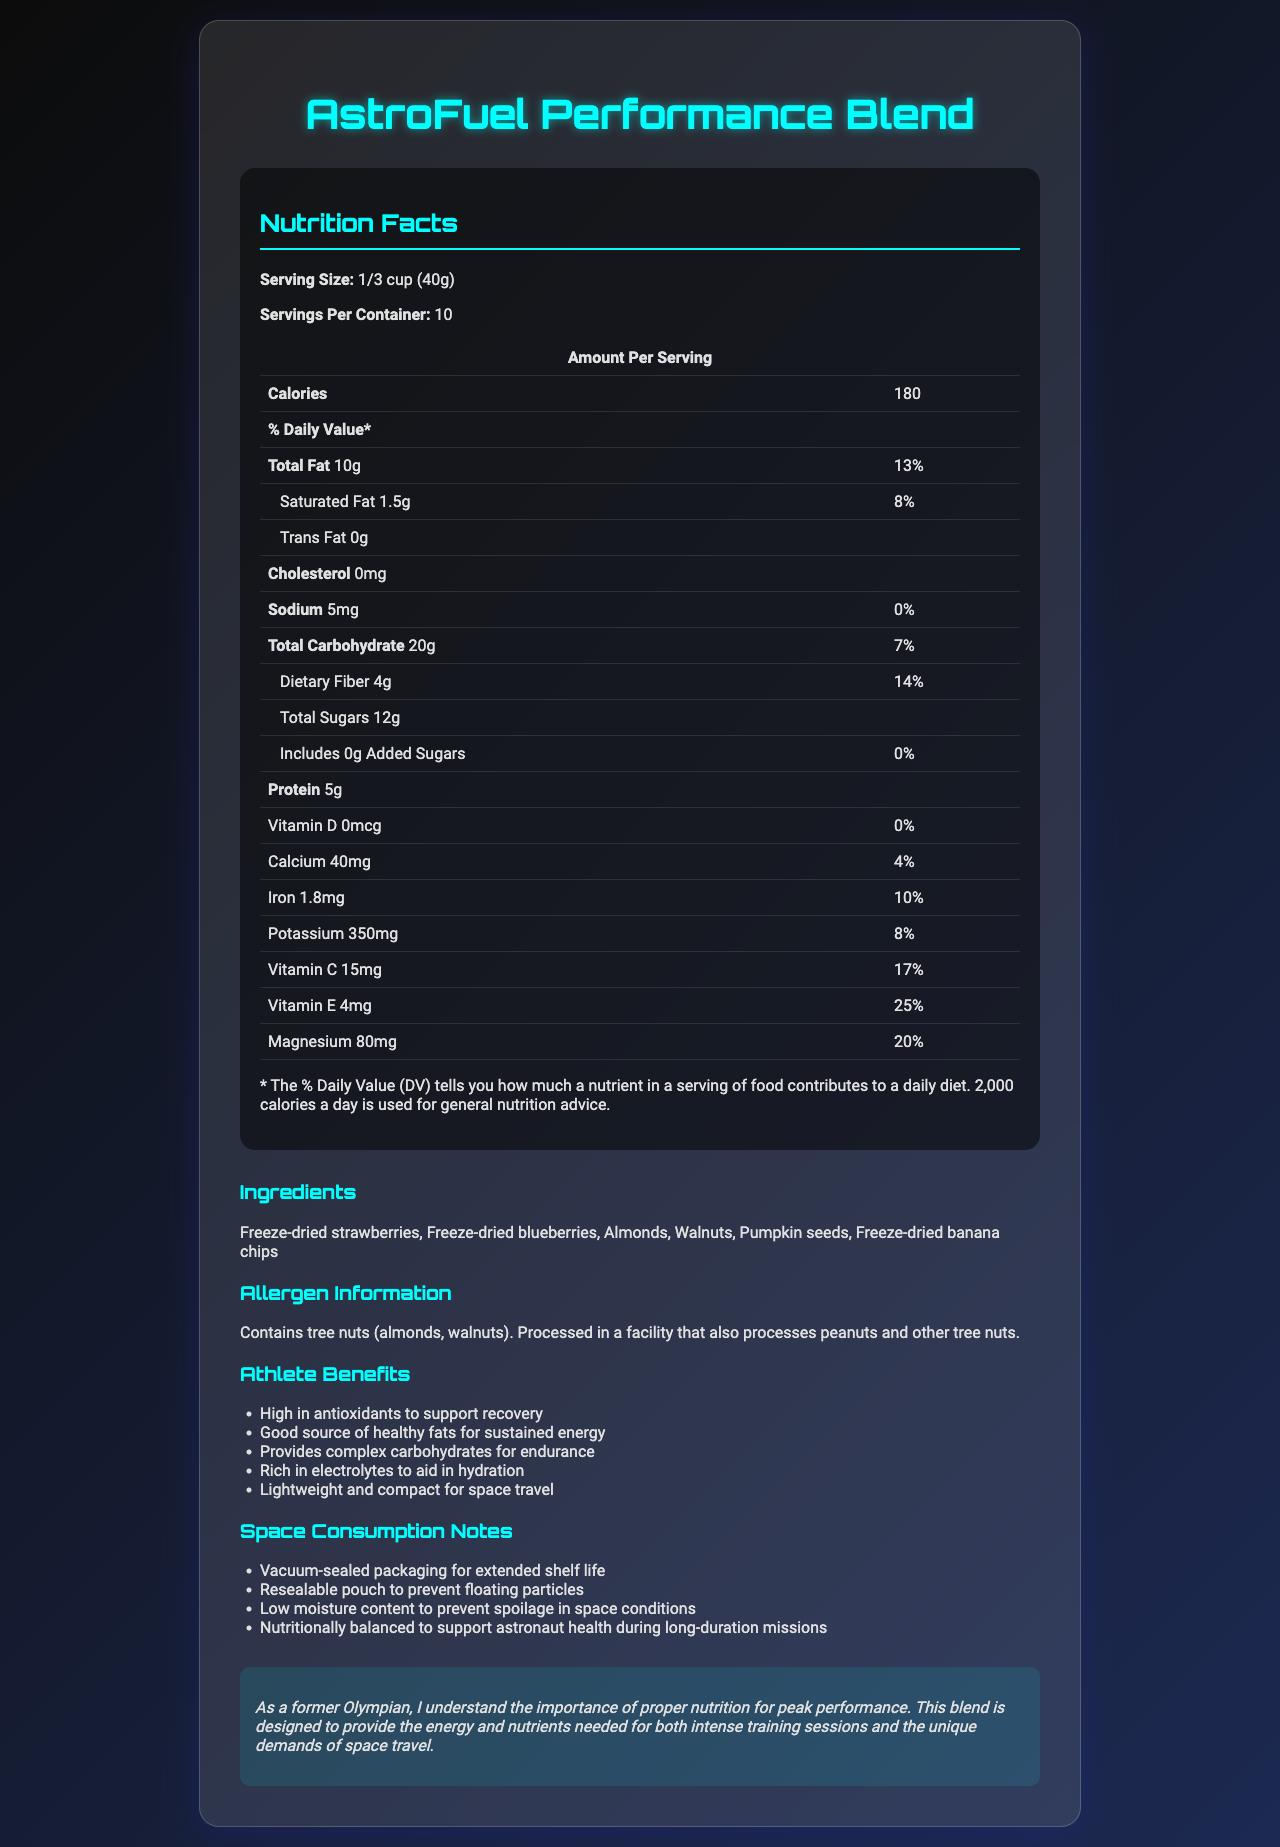what is the serving size? The serving size is explicitly mentioned as 1/3 cup (40g) under the Nutrition Facts section.
Answer: 1/3 cup (40g) how many calories are there per serving? The number of calories per serving is listed as 180 in the Amount Per Serving section of the Nutrition Facts.
Answer: 180 how much total fat does one serving contain? The Total Fat content per serving is shown as 10g in the table under the Nutrition Facts.
Answer: 10g what is the daily value percentage of dietary fiber per serving? The % Daily Value for Dietary Fiber is mentioned as 14% in the Nutrition Facts table.
Answer: 14% what are the primary ingredients in this product? The Ingredients section lists these items as the main ingredients.
Answer: Freeze-dried strawberries, Freeze-dried blueberries, Almonds, Walnuts, Pumpkin seeds, Freeze-dried banana chips does this product contain cholesterol? The Nutrition Facts state that the product contains 0mg of cholesterol, which means it does not contain cholesterol.
Answer: No how much sodium is in one serving? The sodium content per serving is listed as 5mg in the Nutrition Facts.
Answer: 5mg which of the following ingredients does the mix contain? A. Almonds B. Cashews C. Pine nuts D. Peanuts The Ingredients section lists Almonds, but not Cashews, Pine nuts, or Peanuts.
Answer: A. Almonds what benefits are specifically mentioned for athletes? I. High in antioxidants II. Good source of healthy fats III. Increased muscle mass IV. Rich in electrolytes The Athlete Benefits section lists high antioxidants, healthy fats, and rich in electrolytes, but does not mention increased muscle mass.
Answer: I, II, IV is this product suitable for space travel? The Space Consumption Notes section lists multiple features that make this product suitable for space travel.
Answer: Yes summarize the main idea of the document. The document includes information about serving sizes, nutritional content, ingredients, allergen information, and special notes for both athletes and astronauts, emphasizing its high nutrient density and usefulness in strenuous conditions.
Answer: The document provides detailed nutrition facts for the AstroFuel Performance Blend, describes its ingredients, highlights its benefits for athletes, and explains its suitability for space travel. can you find out the price of this product from the document? The document does not provide any information about the price of the AstroFuel Performance Blend.
Answer: Cannot be determined 